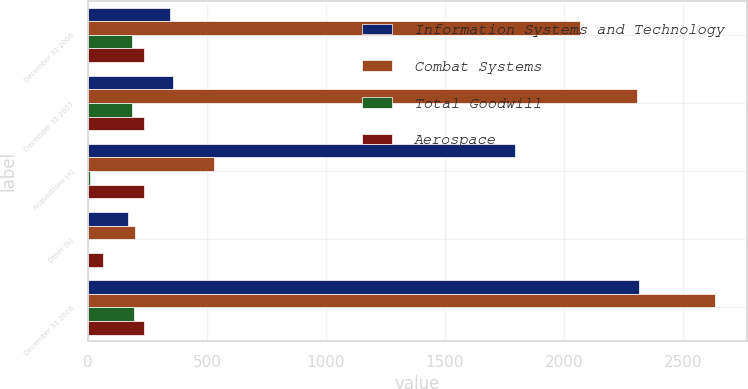<chart> <loc_0><loc_0><loc_500><loc_500><stacked_bar_chart><ecel><fcel>December 31 2006<fcel>December 31 2007<fcel>Acquisitions (a)<fcel>Other (b)<fcel>December 31 2008<nl><fcel>Information Systems and Technology<fcel>343<fcel>355<fcel>1795<fcel>166<fcel>2316<nl><fcel>Combat Systems<fcel>2069<fcel>2308<fcel>529<fcel>199<fcel>2638<nl><fcel>Total Goodwill<fcel>185<fcel>185<fcel>6<fcel>1<fcel>192<nl><fcel>Aerospace<fcel>234<fcel>234<fcel>234<fcel>61<fcel>234<nl></chart> 